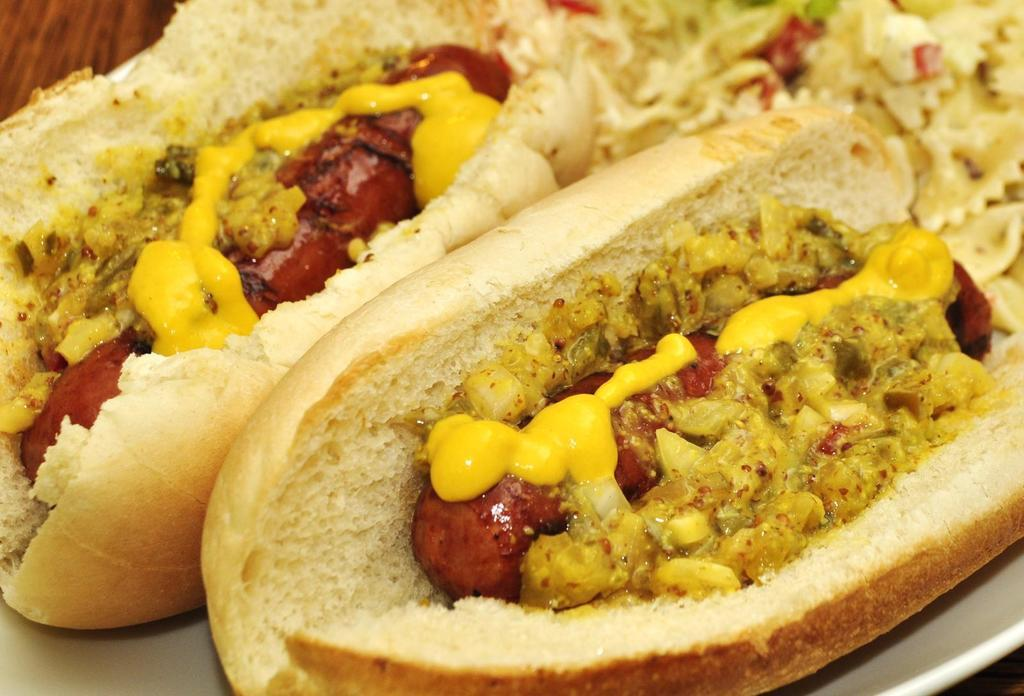What type of food can be seen in the image? The image contains food, but the specific type cannot be determined from the provided facts. What colors are present in the food? The food has white, cream, red, and yellow colors. How is the food arranged in the image? The food is in a plate. What type of rake is used to prepare the food in the image? There is no rake present in the image, and no information about preparing the food is provided. 